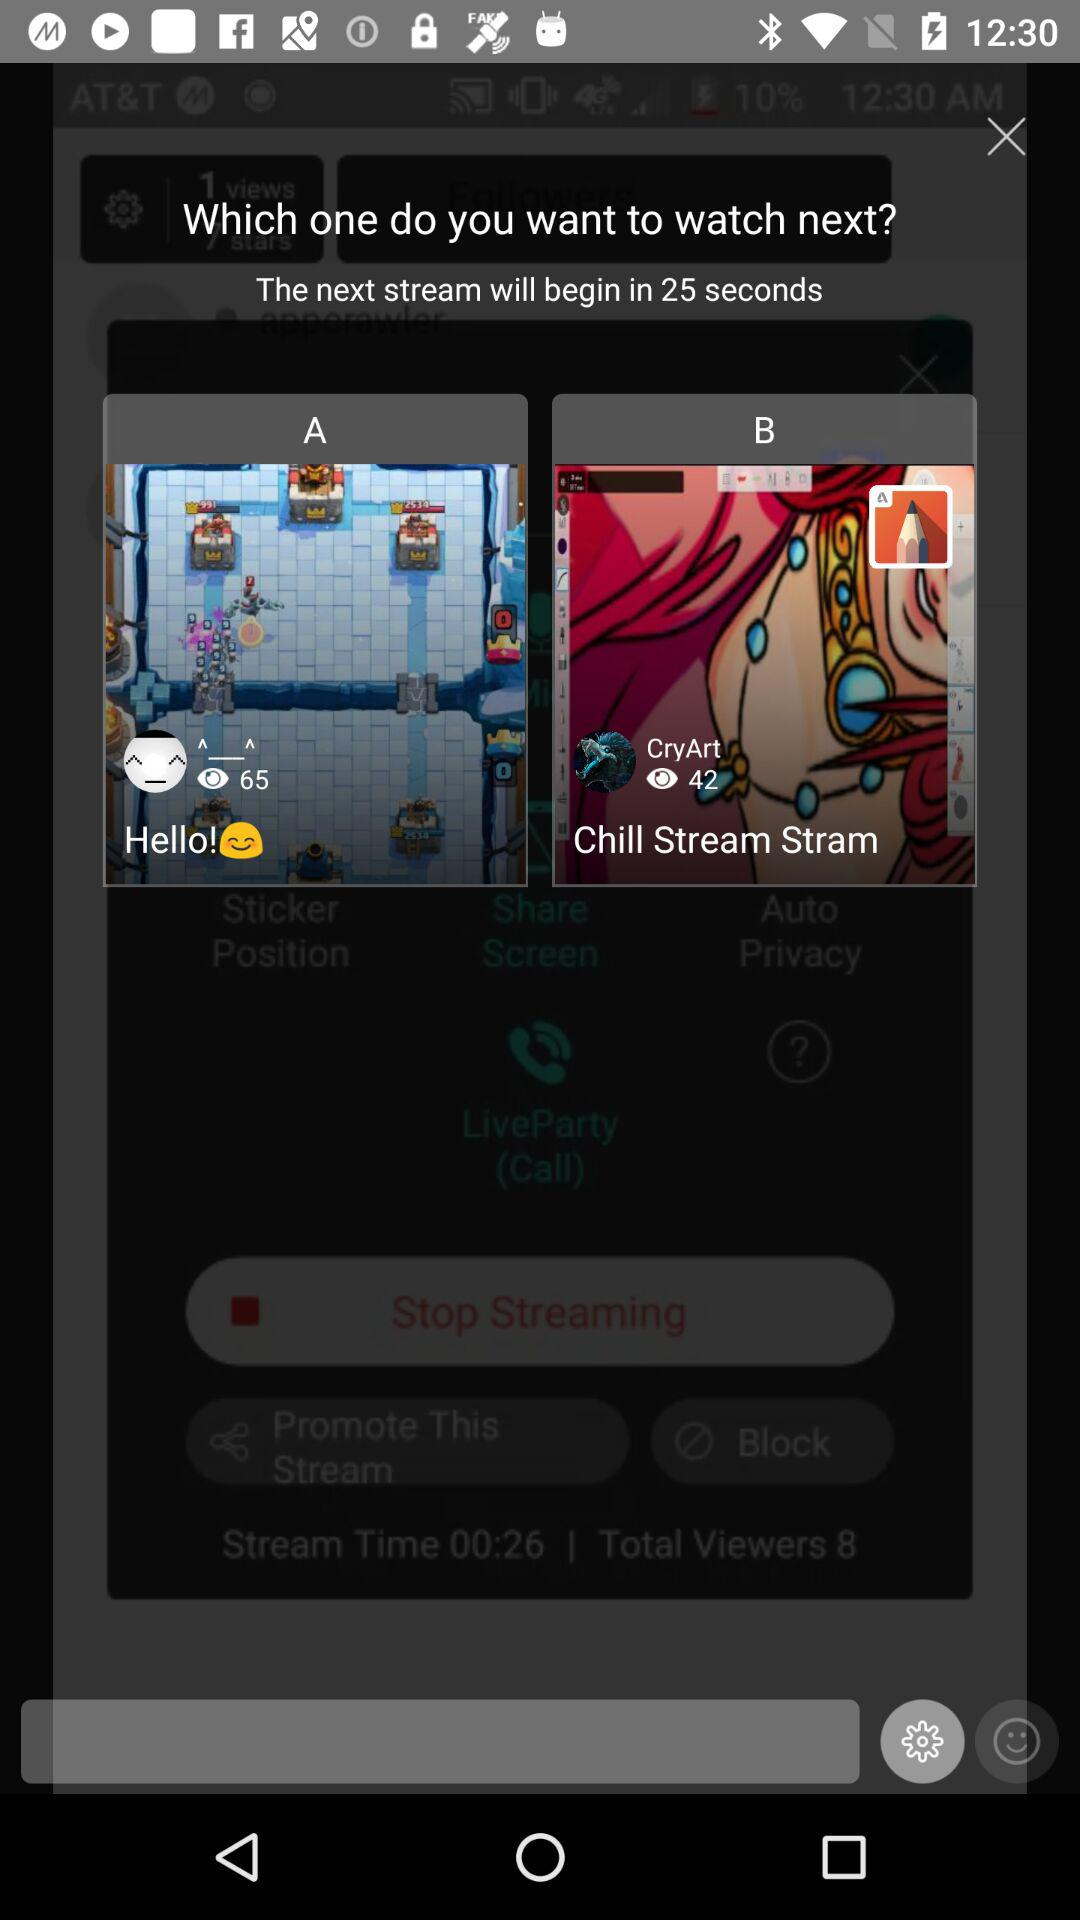What is the number of viewers on the "Hello!" stream? The number of viewers is 65. 